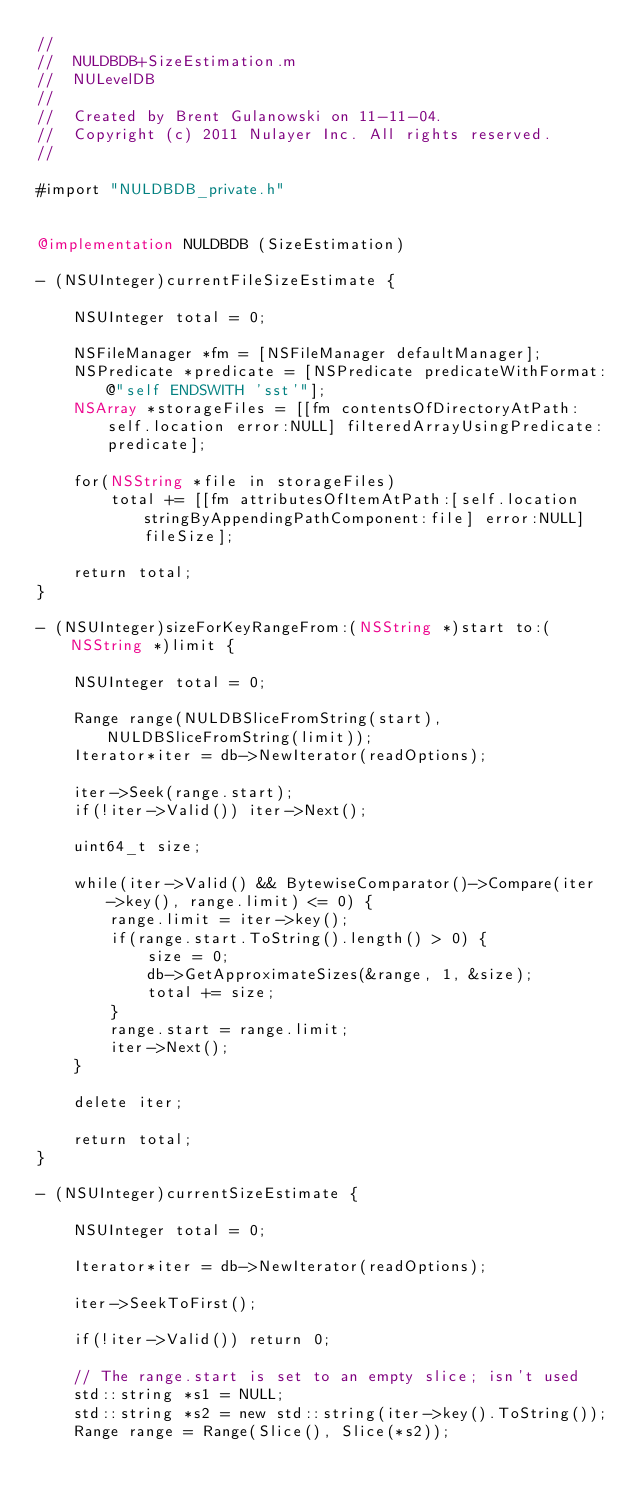<code> <loc_0><loc_0><loc_500><loc_500><_ObjectiveC_>//
//  NULDBDB+SizeEstimation.m
//  NULevelDB
//
//  Created by Brent Gulanowski on 11-11-04.
//  Copyright (c) 2011 Nulayer Inc. All rights reserved.
//

#import "NULDBDB_private.h"


@implementation NULDBDB (SizeEstimation)

- (NSUInteger)currentFileSizeEstimate {
    
    NSUInteger total = 0;
    
    NSFileManager *fm = [NSFileManager defaultManager];
    NSPredicate *predicate = [NSPredicate predicateWithFormat:@"self ENDSWITH 'sst'"];
    NSArray *storageFiles = [[fm contentsOfDirectoryAtPath:self.location error:NULL] filteredArrayUsingPredicate:predicate];
    
    for(NSString *file in storageFiles)
        total += [[fm attributesOfItemAtPath:[self.location stringByAppendingPathComponent:file] error:NULL] fileSize];
    
    return total;
}

- (NSUInteger)sizeForKeyRangeFrom:(NSString *)start to:(NSString *)limit {
    
    NSUInteger total = 0;
    
    Range range(NULDBSliceFromString(start), NULDBSliceFromString(limit));
    Iterator*iter = db->NewIterator(readOptions);
    
    iter->Seek(range.start);
    if(!iter->Valid()) iter->Next();
    
    uint64_t size;
    
    while(iter->Valid() && BytewiseComparator()->Compare(iter->key(), range.limit) <= 0) {
        range.limit = iter->key();
        if(range.start.ToString().length() > 0) {
            size = 0;
            db->GetApproximateSizes(&range, 1, &size);
            total += size;
        }
        range.start = range.limit;
        iter->Next();
    }
    
    delete iter;
    
    return total;
}

- (NSUInteger)currentSizeEstimate {
    
    NSUInteger total = 0;
    
    Iterator*iter = db->NewIterator(readOptions);
    
    iter->SeekToFirst();
    
    if(!iter->Valid()) return 0;
    
    // The range.start is set to an empty slice; isn't used
    std::string *s1 = NULL;
    std::string *s2 = new std::string(iter->key().ToString());
    Range range = Range(Slice(), Slice(*s2));</code> 